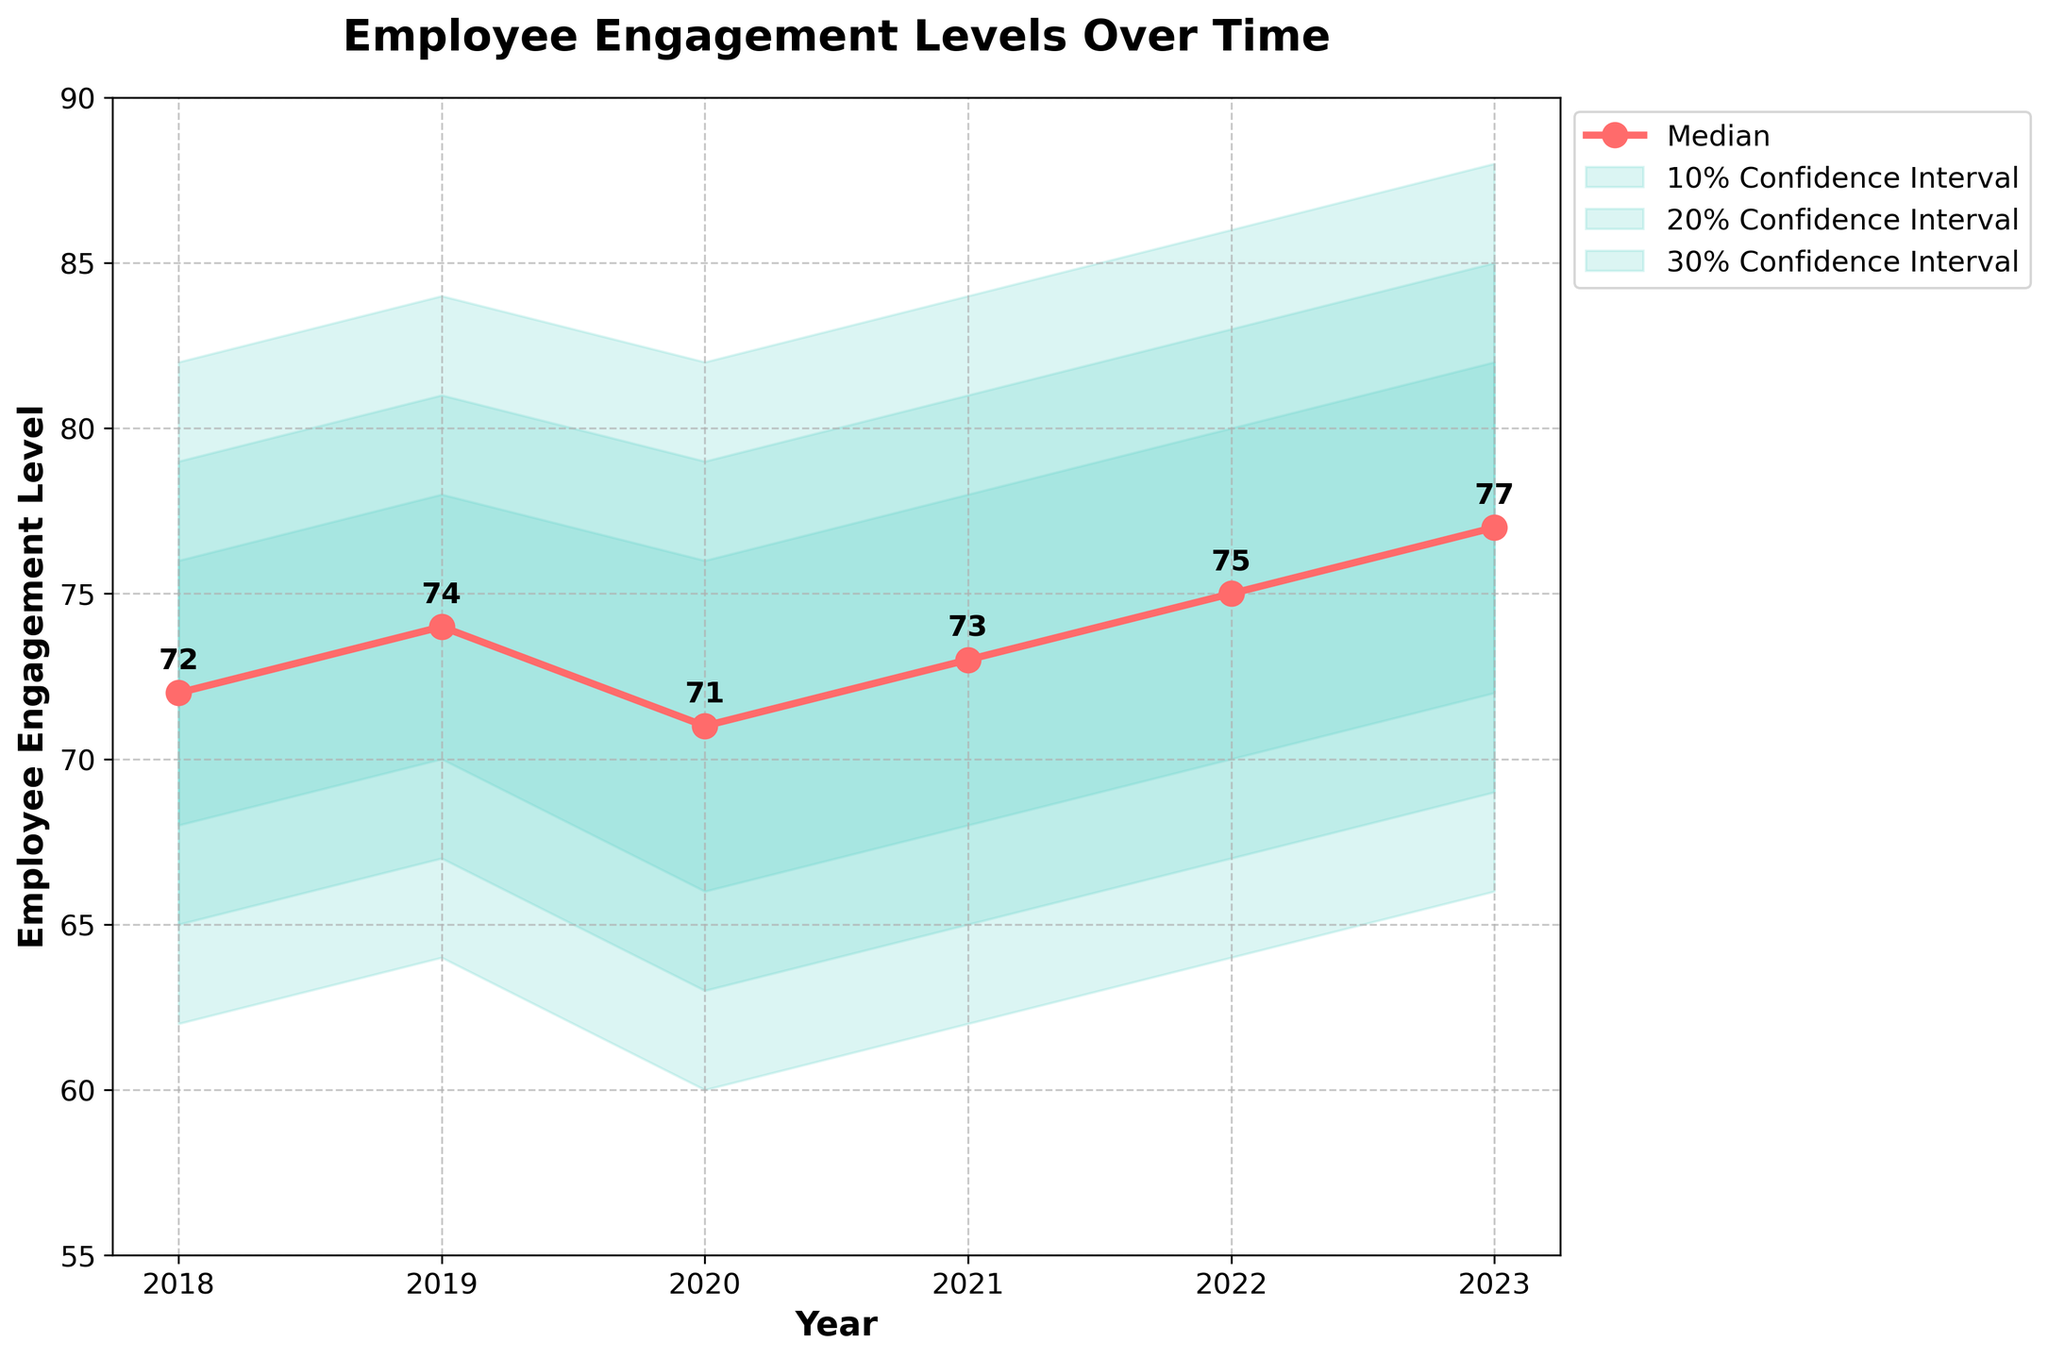What is the title of the plot? The title of the plot is usually located at the top of the figure. Here, it reads "Employee Engagement Levels Over Time."
Answer: Employee Engagement Levels Over Time How many years are represented in the plot? The x-axis of the plot represents the years. Counting these, we see that the years 2018, 2019, 2020, 2021, 2022, and 2023 are included.
Answer: 6 What is the median employee engagement level in 2023? The median employee engagement level is represented by the red line with circular markers. For the year 2023, the median value is 77.
Answer: 77 Which year has the lowest median employee engagement level? By looking at the median (red line with circular markers), we can see the lowest point is at the year 2020, where the median value is 71.
Answer: 2020 What is the range of the 20% confidence interval in 2021? Locate 2021 on the x-axis and reference the 20% confidence interval. The lower and upper boundaries are 65 and 81, respectively. Calculate the range: 81 - 65 = 16.
Answer: 16 How does the median employee engagement level in 2022 compare to 2018? The median level for 2018 is 72, and for 2022 it is 75. Comparing these two values, 2022 is higher than 2018 by 3 points.
Answer: 2022 is higher by 3 Is the employee engagement trend generally increasing, decreasing, or stable? Observing the median values from 2018 to 2023 (72, 74, 71, 73, 75, 77), there is a general increasing trend despite some fluctuations.
Answer: Increasing What is the width of the 10% confidence interval in 2020? In 2020, the 10% confidence interval has lower and upper bounds of 66 and 76. Calculate the width as follows: 76 - 66 = 10.
Answer: 10 Between which two consecutive years is the greatest increase in median employee engagement level? Comparing the median levels: 
2018 to 2019: 74 - 72 = 2,
2019 to 2020: 71 - 74 = -3,
2020 to 2021: 73 - 71 = 2,
2021 to 2022: 75 - 73 = 2,
2022 to 2023: 77 - 75 = 2. 
The greatest increase is from 2021 to 2022, 2022 to 2023, and 2018 to 2019, tied at an increase of 2 points.
Answer: 2021-2022, 2022-2023, 2018-2019 Does any year have a median engagement level outside the 20% confidence intervals of all other years? To resolve this, check if any median value falls outside the overlapping range of all other years' 20% confidence intervals. No single year’s median appears completely outside the combined intervals.
Answer: No 